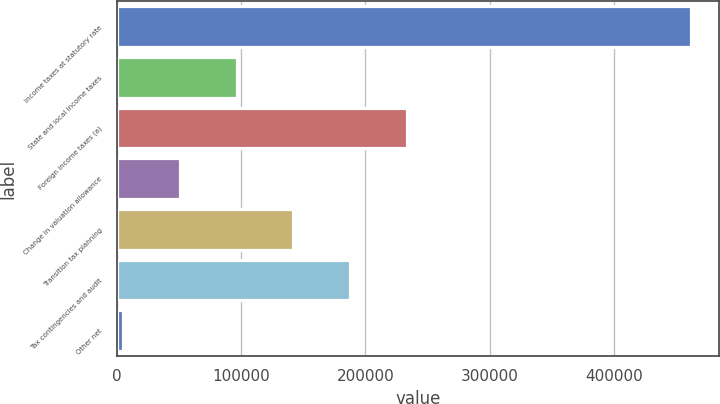Convert chart. <chart><loc_0><loc_0><loc_500><loc_500><bar_chart><fcel>Income taxes at statutory rate<fcel>State and local income taxes<fcel>Foreign income taxes (a)<fcel>Change in valuation allowance<fcel>Transition tax planning<fcel>Tax contingencies and audit<fcel>Other net<nl><fcel>461250<fcel>96518.8<fcel>233293<fcel>50927.4<fcel>142110<fcel>187702<fcel>5336<nl></chart> 